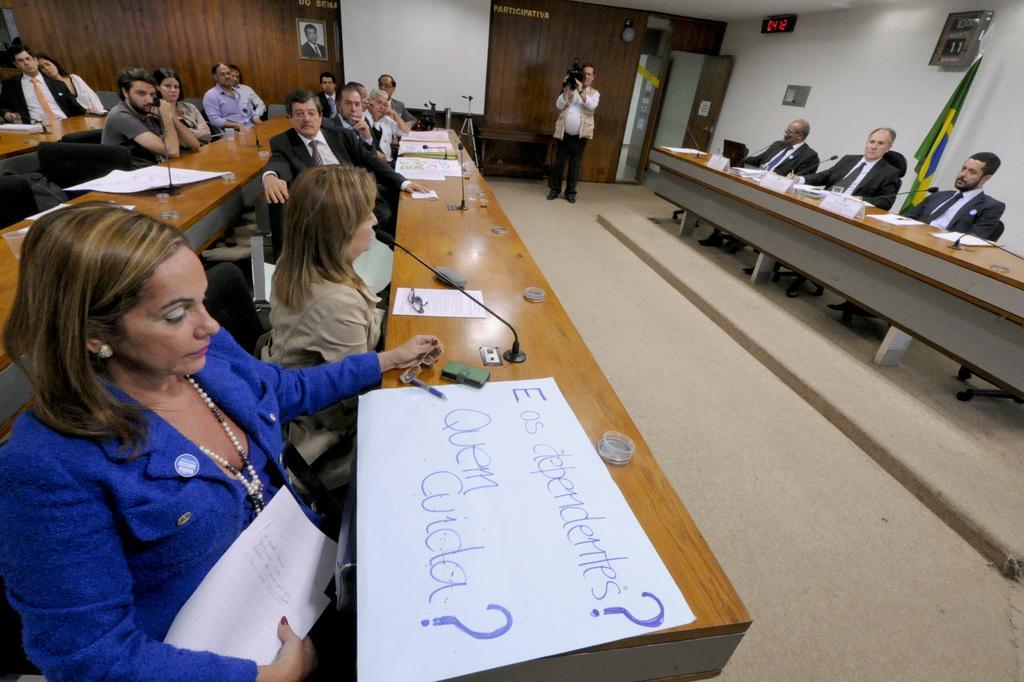Please provide a concise description of this image. In this image there are many people sitting on the chairs at the tables. On the tables there are microphones, papers, spectacles and pens. Behind them there is a wall. There is a picture frame on the wall. Beside the frame there is a projector board on the wall. In front of the board there are tripod stands. Beside the stands there is a man standing. He is holding a camera in his hand. Behind him there is a door. Above the door there is a digital clock on the wall. In the top right there is a flag behind the table. 